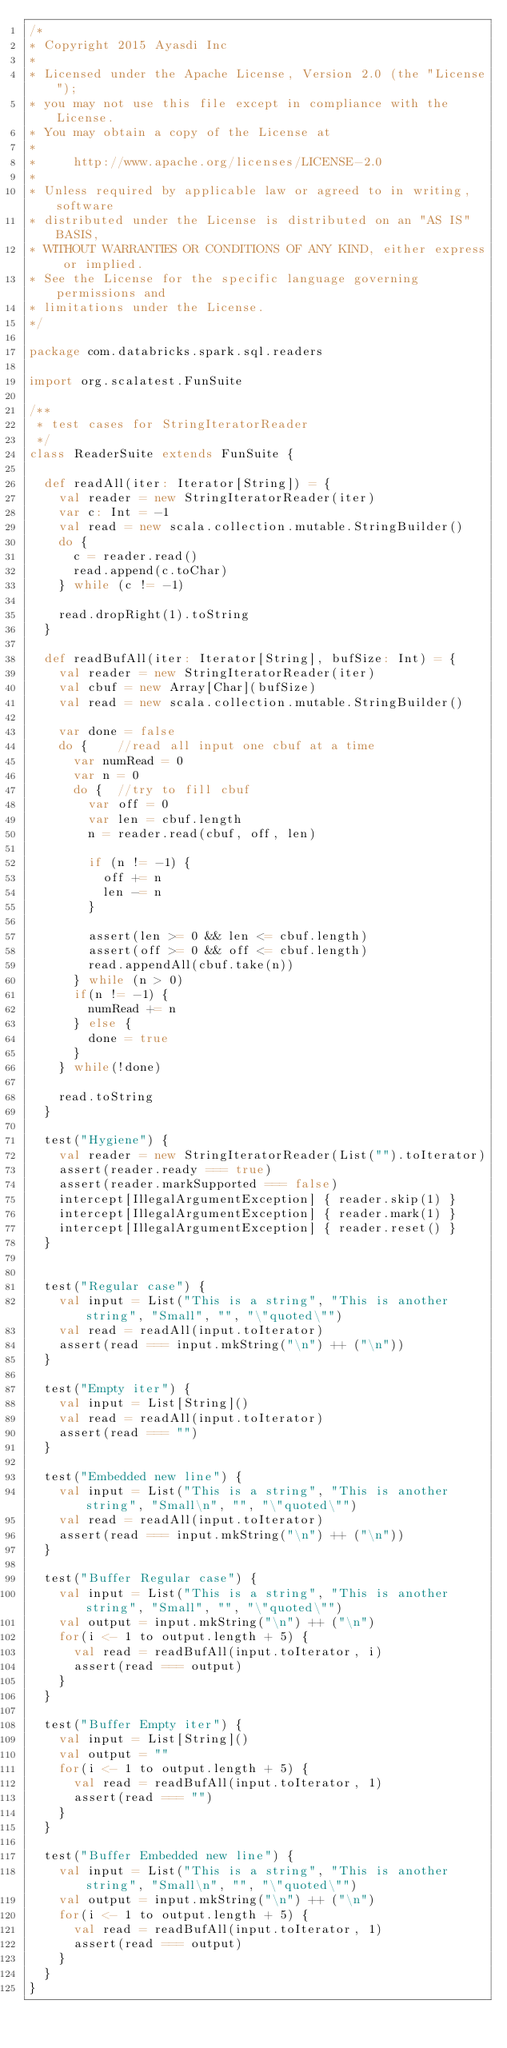<code> <loc_0><loc_0><loc_500><loc_500><_Scala_>/*
* Copyright 2015 Ayasdi Inc
*
* Licensed under the Apache License, Version 2.0 (the "License");
* you may not use this file except in compliance with the License.
* You may obtain a copy of the License at
*
*     http://www.apache.org/licenses/LICENSE-2.0
*
* Unless required by applicable law or agreed to in writing, software
* distributed under the License is distributed on an "AS IS" BASIS,
* WITHOUT WARRANTIES OR CONDITIONS OF ANY KIND, either express or implied.
* See the License for the specific language governing permissions and
* limitations under the License.
*/

package com.databricks.spark.sql.readers

import org.scalatest.FunSuite

/**
 * test cases for StringIteratorReader
 */
class ReaderSuite extends FunSuite {

  def readAll(iter: Iterator[String]) = {
    val reader = new StringIteratorReader(iter)
    var c: Int = -1
    val read = new scala.collection.mutable.StringBuilder()
    do {
      c = reader.read()
      read.append(c.toChar)
    } while (c != -1)

    read.dropRight(1).toString
  }

  def readBufAll(iter: Iterator[String], bufSize: Int) = {
    val reader = new StringIteratorReader(iter)
    val cbuf = new Array[Char](bufSize)
    val read = new scala.collection.mutable.StringBuilder()

    var done = false
    do {    //read all input one cbuf at a time
      var numRead = 0
      var n = 0
      do {  //try to fill cbuf
        var off = 0
        var len = cbuf.length
        n = reader.read(cbuf, off, len)

        if (n != -1) {
          off += n
          len -= n
        }

        assert(len >= 0 && len <= cbuf.length)
        assert(off >= 0 && off <= cbuf.length)
        read.appendAll(cbuf.take(n))
      } while (n > 0)
      if(n != -1) {
        numRead += n
      } else {
        done = true
      }
    } while(!done)

    read.toString
  }

  test("Hygiene") {
    val reader = new StringIteratorReader(List("").toIterator)
    assert(reader.ready === true)
    assert(reader.markSupported === false)
    intercept[IllegalArgumentException] { reader.skip(1) }
    intercept[IllegalArgumentException] { reader.mark(1) }
    intercept[IllegalArgumentException] { reader.reset() }
  }


  test("Regular case") {
    val input = List("This is a string", "This is another string", "Small", "", "\"quoted\"")
    val read = readAll(input.toIterator)
    assert(read === input.mkString("\n") ++ ("\n"))
  }

  test("Empty iter") {
    val input = List[String]()
    val read = readAll(input.toIterator)
    assert(read === "")
  }

  test("Embedded new line") {
    val input = List("This is a string", "This is another string", "Small\n", "", "\"quoted\"")
    val read = readAll(input.toIterator)
    assert(read === input.mkString("\n") ++ ("\n"))
  }

  test("Buffer Regular case") {
    val input = List("This is a string", "This is another string", "Small", "", "\"quoted\"")
    val output = input.mkString("\n") ++ ("\n")
    for(i <- 1 to output.length + 5) {
      val read = readBufAll(input.toIterator, i)
      assert(read === output)
    }
  }

  test("Buffer Empty iter") {
    val input = List[String]()
    val output = ""
    for(i <- 1 to output.length + 5) {
      val read = readBufAll(input.toIterator, 1)
      assert(read === "")
    }
  }

  test("Buffer Embedded new line") {
    val input = List("This is a string", "This is another string", "Small\n", "", "\"quoted\"")
    val output = input.mkString("\n") ++ ("\n")
    for(i <- 1 to output.length + 5) {
      val read = readBufAll(input.toIterator, 1)
      assert(read === output)
    }
  }
}
</code> 